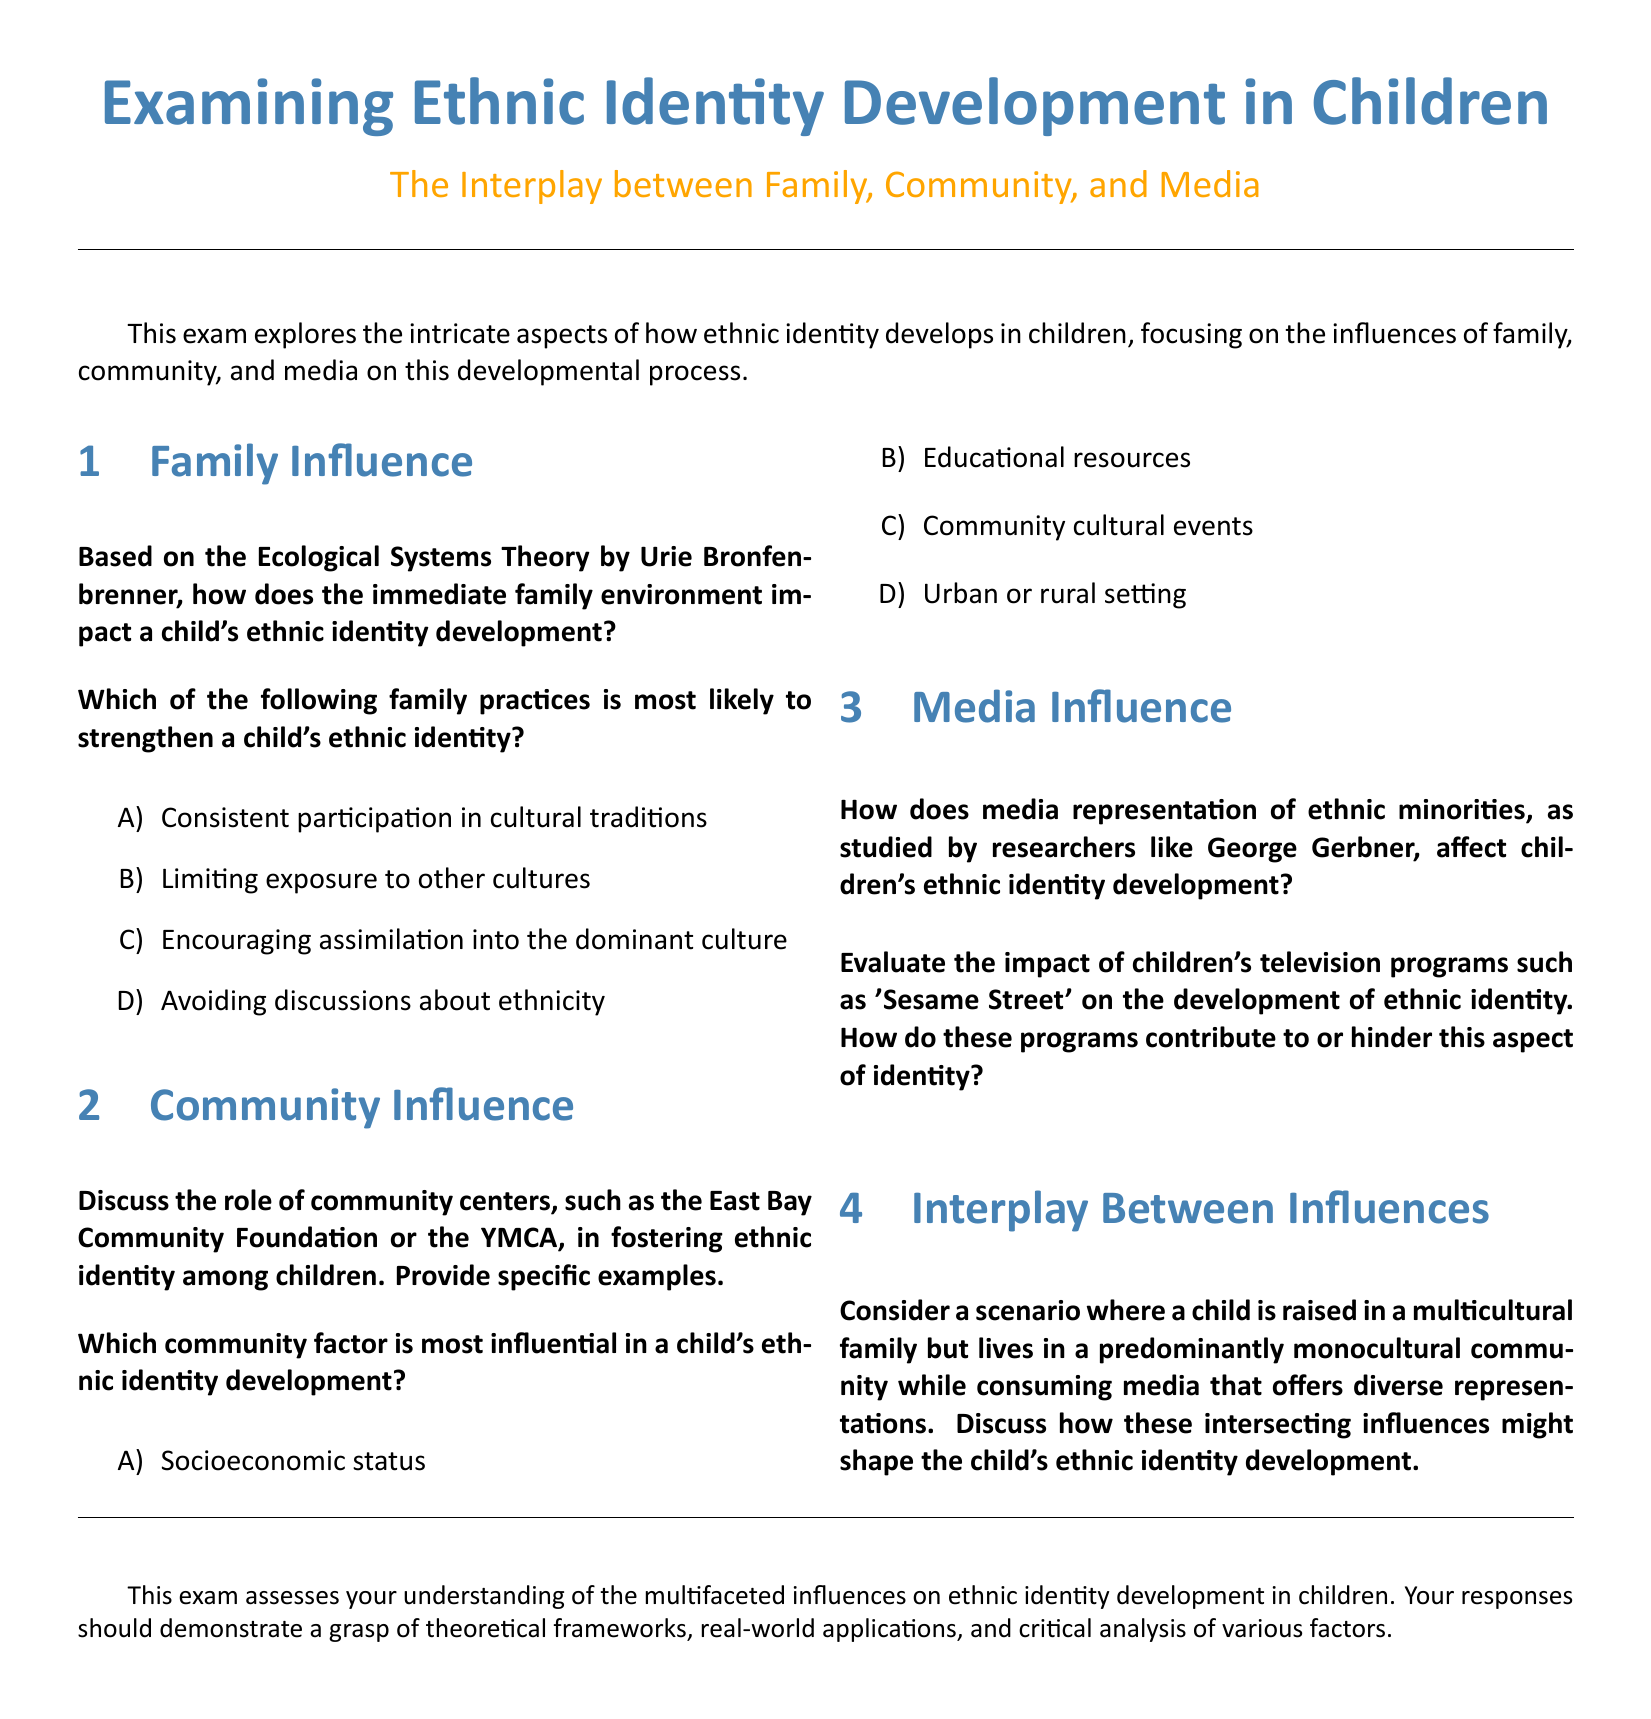What is the title of the document? The title provides the main subject of the document, which is "Examining Ethnic Identity Development in Children".
Answer: Examining Ethnic Identity Development in Children What is the subtitle of the document? The subtitle describes the focus area of the research, which emphasizes the influences being studied.
Answer: The Interplay between Family, Community, and Media Who proposed the Ecological Systems Theory mentioned in the exam? The document attributes the theory to a specific researcher known for this framework.
Answer: Urie Bronfenbrenner Which family practice is most likely to strengthen a child's ethnic identity? The exam lists multiple family practices and asks for the most effective, which is clearly stated.
Answer: Consistent participation in cultural traditions What community factor is most influential in a child's ethnic identity development? The exam provides options and seeks the one that has the greatest impact.
Answer: Community cultural events Which children's television program is evaluated for its impact on ethnic identity? The document names a specific program that is well-known for its educational content.
Answer: Sesame Street What element of the exam focuses on the interplay of various influences? The section title indicates that this part discusses the intersection of multiple factors affecting identity.
Answer: Interplay Between Influences What is the main objective of the exam? The document explicitly states its purpose in assessing understanding regarding a significant topic.
Answer: Understanding the multifaceted influences on ethnic identity development in children 